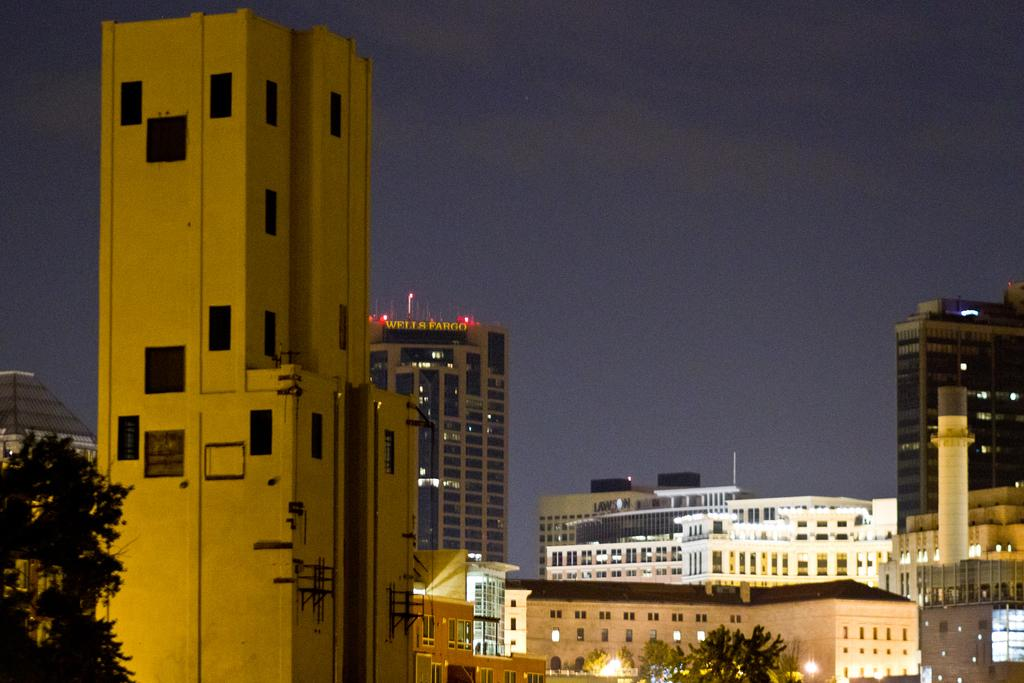What is located in the left bottom corner of the image? There is a tree in the left bottom corner of the image. What can be seen in the background of the image? There are buildings, trees, lights, and the sky visible in the background of the image. Can you see a squirrel playing a record with a fork in the image? There is no squirrel, record, or fork present in the image. 